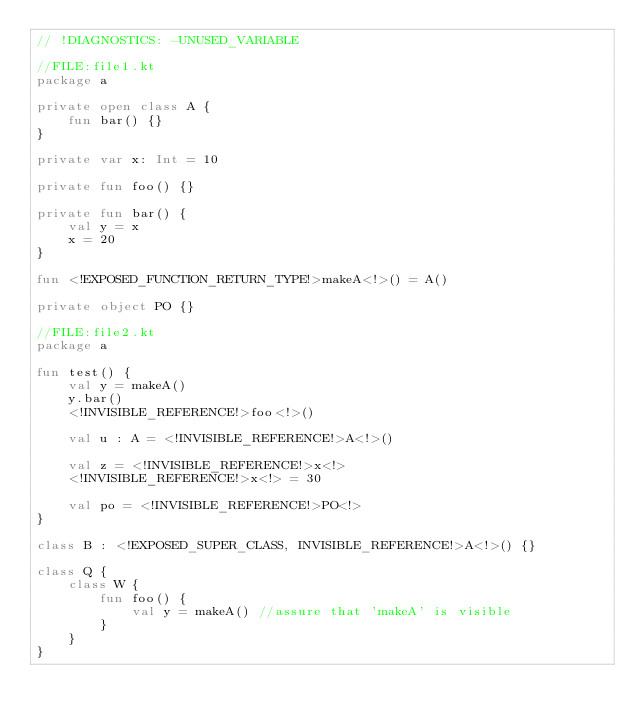Convert code to text. <code><loc_0><loc_0><loc_500><loc_500><_Kotlin_>// !DIAGNOSTICS: -UNUSED_VARIABLE

//FILE:file1.kt
package a

private open class A {
    fun bar() {}
}

private var x: Int = 10

private fun foo() {}

private fun bar() {
    val y = x
    x = 20
}

fun <!EXPOSED_FUNCTION_RETURN_TYPE!>makeA<!>() = A()

private object PO {}

//FILE:file2.kt
package a

fun test() {
    val y = makeA()
    y.bar()
    <!INVISIBLE_REFERENCE!>foo<!>()

    val u : A = <!INVISIBLE_REFERENCE!>A<!>()

    val z = <!INVISIBLE_REFERENCE!>x<!>
    <!INVISIBLE_REFERENCE!>x<!> = 30

    val po = <!INVISIBLE_REFERENCE!>PO<!>
}

class B : <!EXPOSED_SUPER_CLASS, INVISIBLE_REFERENCE!>A<!>() {}

class Q {
    class W {
        fun foo() {
            val y = makeA() //assure that 'makeA' is visible
        }
    }
}
</code> 